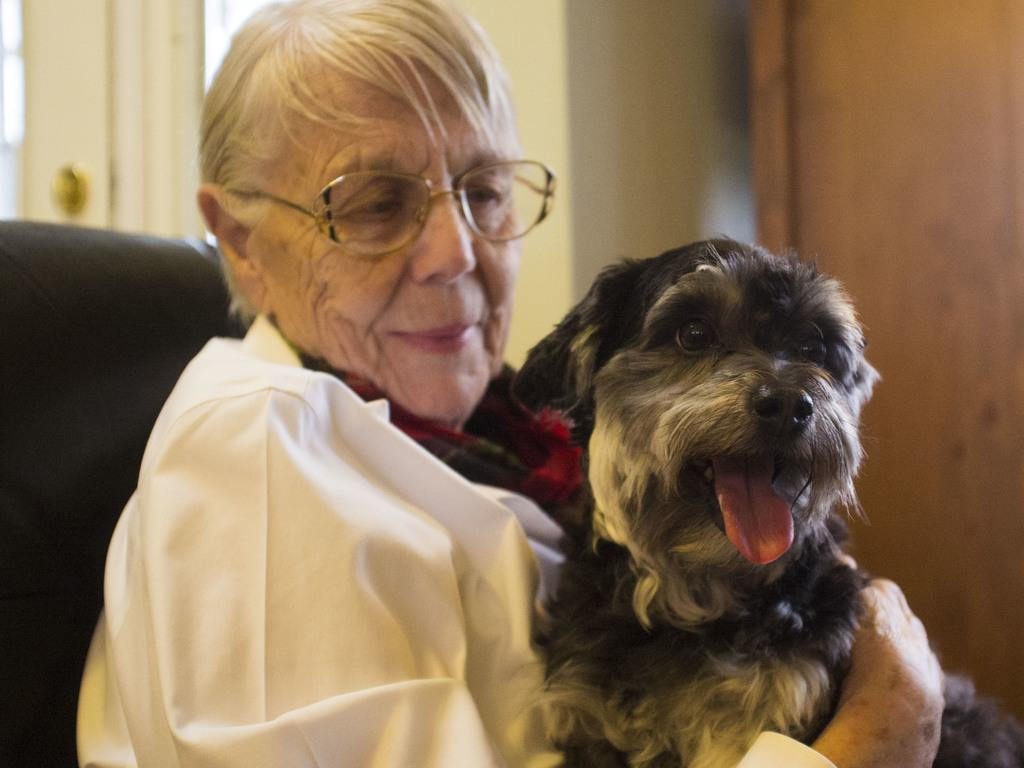Who is the main subject in the image? There is a woman in the image. What is the woman holding in the image? The woman is holding a dog. What color is the shirt the woman is wearing? The woman is wearing a white color shirt. What accessory is the woman wearing on her face? The woman is wearing spectacles. What is the woman sitting on in the image? The woman is sitting on a chair. What can be seen in the background of the image? There is a wall in the background of the image. What type of steam can be seen coming from the dog's ears in the image? There is no steam coming from the dog's ears in the image; the dog is not depicted as producing steam. 